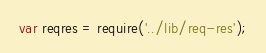Convert code to text. <code><loc_0><loc_0><loc_500><loc_500><_JavaScript_>var reqres = require('../lib/req-res');
</code> 